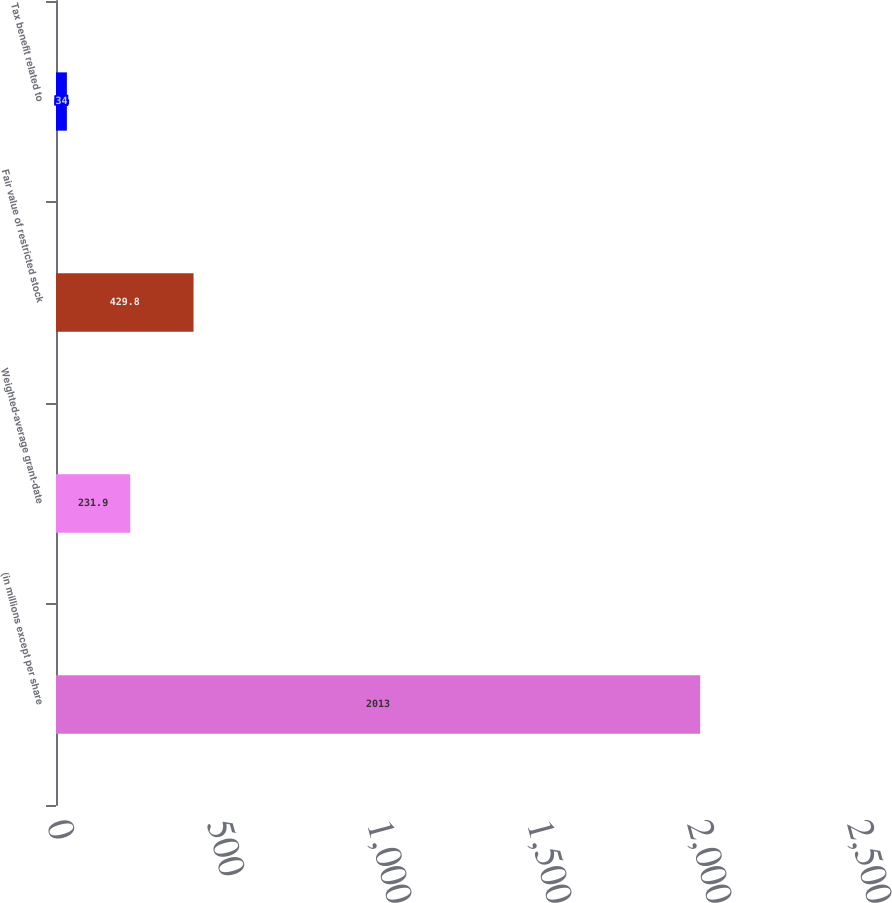Convert chart to OTSL. <chart><loc_0><loc_0><loc_500><loc_500><bar_chart><fcel>(in millions except per share<fcel>Weighted-average grant-date<fcel>Fair value of restricted stock<fcel>Tax benefit related to<nl><fcel>2013<fcel>231.9<fcel>429.8<fcel>34<nl></chart> 